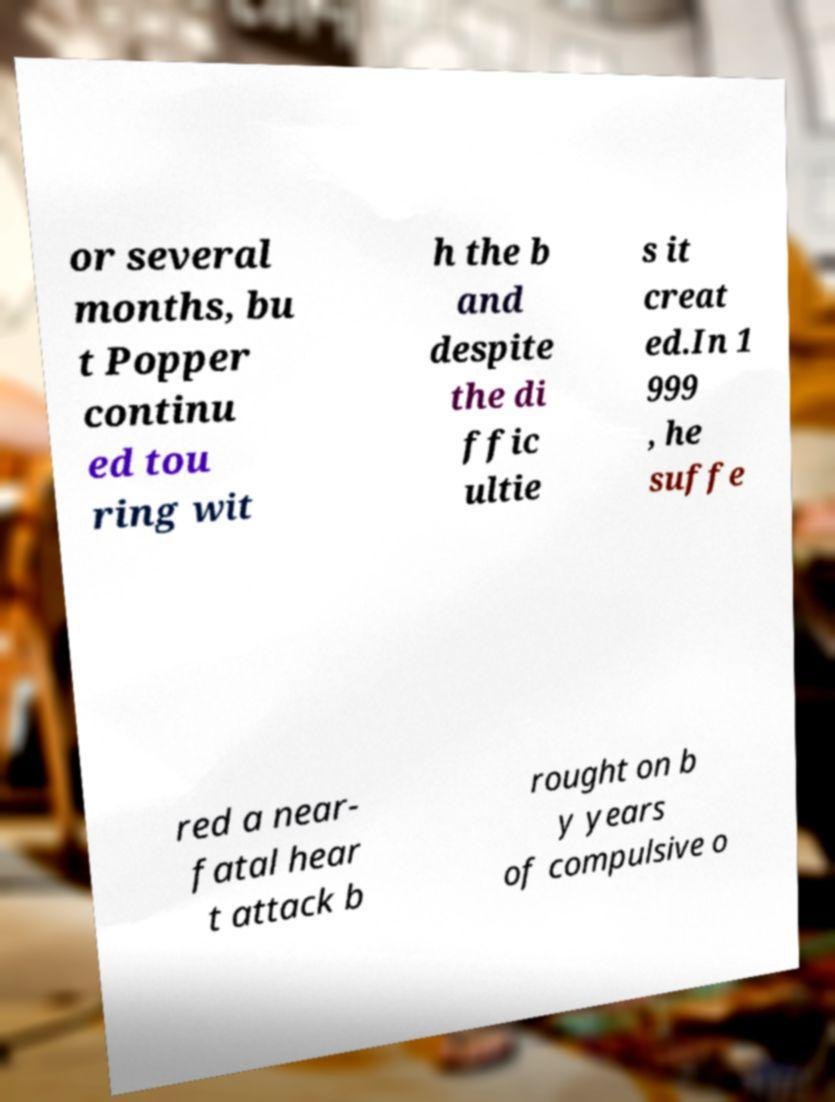Can you read and provide the text displayed in the image?This photo seems to have some interesting text. Can you extract and type it out for me? or several months, bu t Popper continu ed tou ring wit h the b and despite the di ffic ultie s it creat ed.In 1 999 , he suffe red a near- fatal hear t attack b rought on b y years of compulsive o 